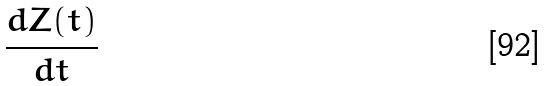Convert formula to latex. <formula><loc_0><loc_0><loc_500><loc_500>\frac { d Z ( t ) } { d t }</formula> 